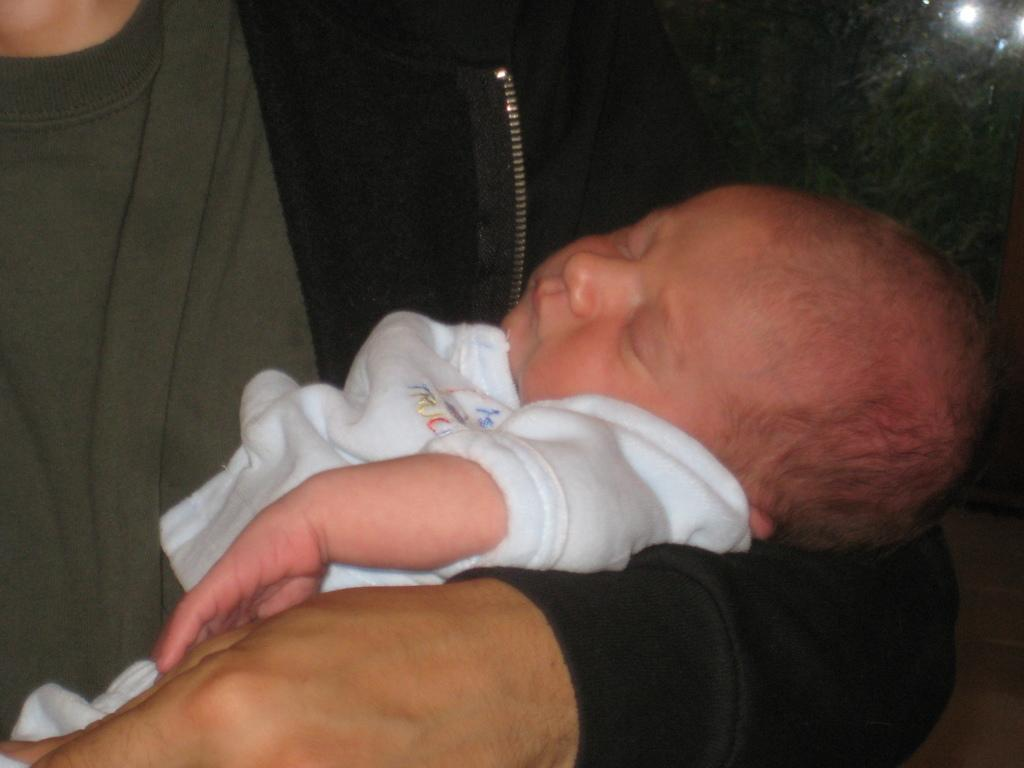Who or what is the main subject in the image? There is a person in the image. What is the person doing in the image? The person is holding a baby. What can be observed about the lighting or color of the background in the image? The background of the image is dark. What type of basket is the person using to carry the tax in the image? There is no basket or tax present in the image; it features a person holding a baby. What kind of drink is the baby holding in the image? There is no drink present in the image; the baby is being held by the person. 